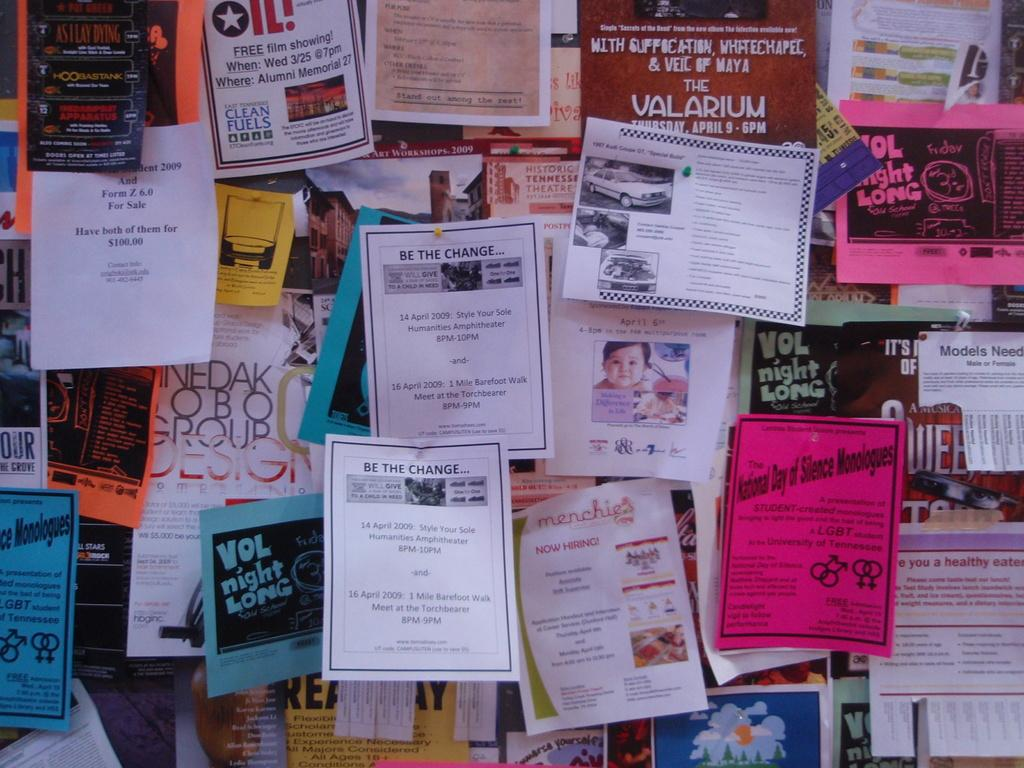<image>
Offer a succinct explanation of the picture presented. Many papers are tacked to a board and one of them is about change. 